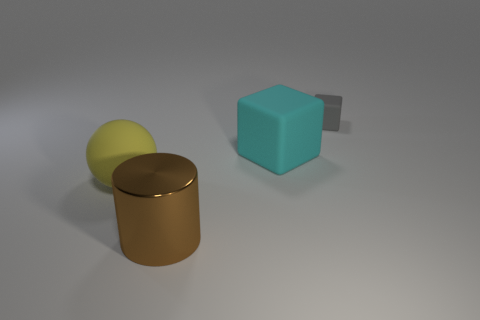Add 4 blue matte things. How many objects exist? 8 Subtract all spheres. How many objects are left? 3 Subtract all large yellow matte spheres. Subtract all small matte objects. How many objects are left? 2 Add 1 brown metal objects. How many brown metal objects are left? 2 Add 4 large green cubes. How many large green cubes exist? 4 Subtract 0 red balls. How many objects are left? 4 